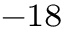<formula> <loc_0><loc_0><loc_500><loc_500>^ { - 1 8 }</formula> 